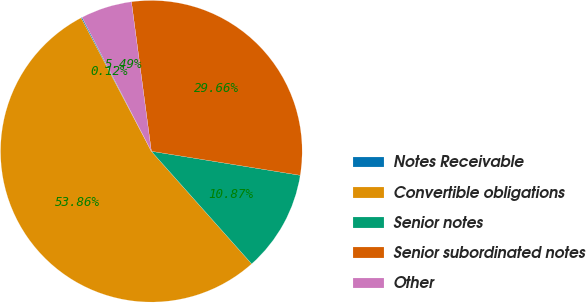Convert chart to OTSL. <chart><loc_0><loc_0><loc_500><loc_500><pie_chart><fcel>Notes Receivable<fcel>Convertible obligations<fcel>Senior notes<fcel>Senior subordinated notes<fcel>Other<nl><fcel>0.12%<fcel>53.87%<fcel>10.87%<fcel>29.66%<fcel>5.49%<nl></chart> 